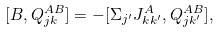Convert formula to latex. <formula><loc_0><loc_0><loc_500><loc_500>[ B , Q ^ { A B } _ { j k } ] = - [ \Sigma _ { j ^ { \prime } } J ^ { A } _ { k k ^ { \prime } } , Q ^ { A B } _ { j k ^ { \prime } } ] ,</formula> 